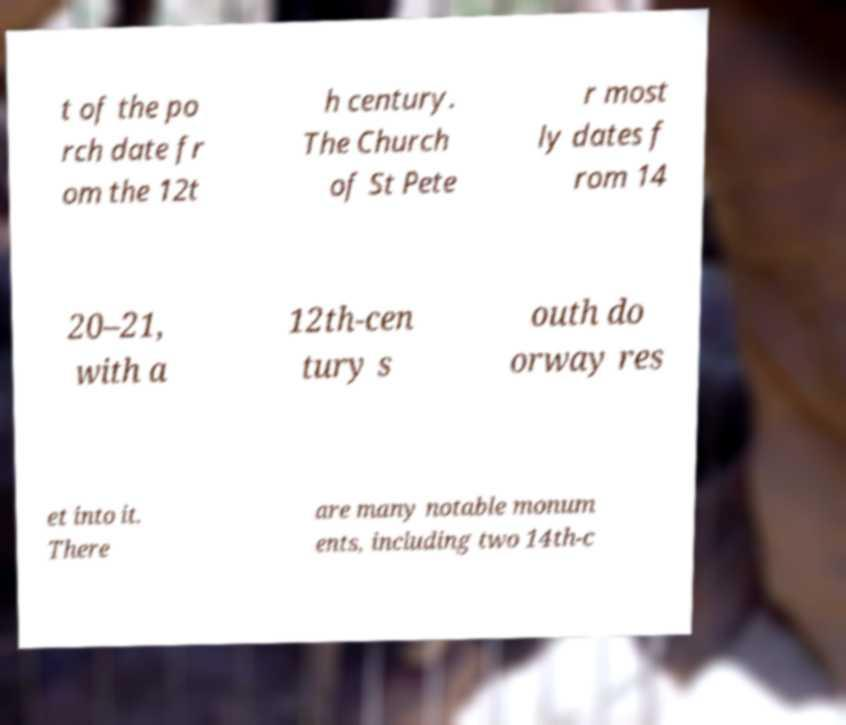For documentation purposes, I need the text within this image transcribed. Could you provide that? t of the po rch date fr om the 12t h century. The Church of St Pete r most ly dates f rom 14 20–21, with a 12th-cen tury s outh do orway res et into it. There are many notable monum ents, including two 14th-c 